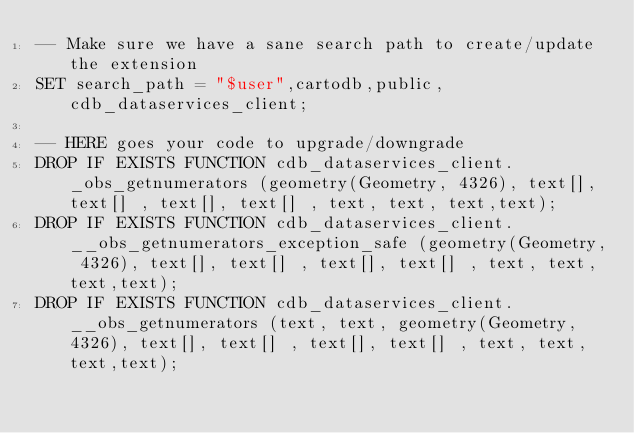<code> <loc_0><loc_0><loc_500><loc_500><_SQL_>-- Make sure we have a sane search path to create/update the extension
SET search_path = "$user",cartodb,public,cdb_dataservices_client;

-- HERE goes your code to upgrade/downgrade
DROP IF EXISTS FUNCTION cdb_dataservices_client._obs_getnumerators (geometry(Geometry, 4326), text[], text[] , text[], text[] , text, text, text,text);
DROP IF EXISTS FUNCTION cdb_dataservices_client.__obs_getnumerators_exception_safe (geometry(Geometry, 4326), text[], text[] , text[], text[] , text, text, text,text);
DROP IF EXISTS FUNCTION cdb_dataservices_client.__obs_getnumerators (text, text, geometry(Geometry, 4326), text[], text[] , text[], text[] , text, text, text,text);
</code> 